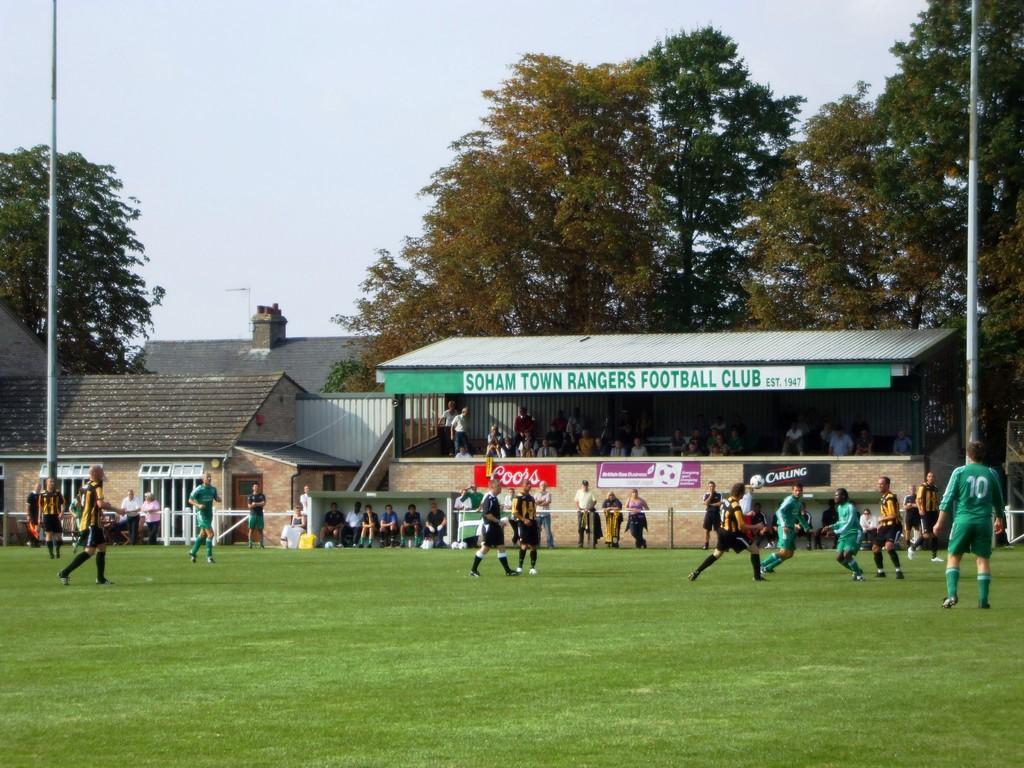What type of club is this?
Your response must be concise. Football. Who is the sponsor on the red banner?
Offer a very short reply. Coors. 